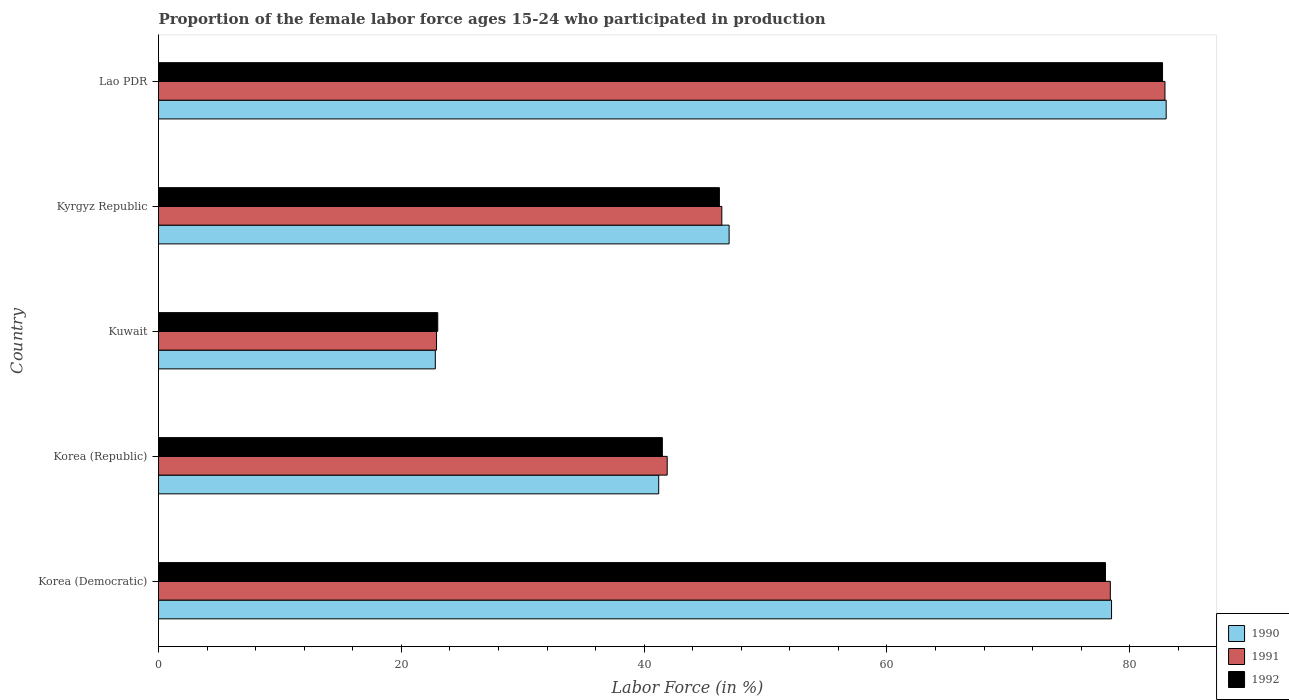How many groups of bars are there?
Your answer should be compact. 5. Are the number of bars on each tick of the Y-axis equal?
Keep it short and to the point. Yes. How many bars are there on the 2nd tick from the top?
Your answer should be very brief. 3. How many bars are there on the 4th tick from the bottom?
Offer a terse response. 3. What is the label of the 5th group of bars from the top?
Offer a terse response. Korea (Democratic). What is the proportion of the female labor force who participated in production in 1991 in Kyrgyz Republic?
Your answer should be compact. 46.4. Across all countries, what is the maximum proportion of the female labor force who participated in production in 1991?
Your answer should be compact. 82.9. Across all countries, what is the minimum proportion of the female labor force who participated in production in 1990?
Give a very brief answer. 22.8. In which country was the proportion of the female labor force who participated in production in 1991 maximum?
Give a very brief answer. Lao PDR. In which country was the proportion of the female labor force who participated in production in 1990 minimum?
Your response must be concise. Kuwait. What is the total proportion of the female labor force who participated in production in 1992 in the graph?
Provide a succinct answer. 271.4. What is the difference between the proportion of the female labor force who participated in production in 1992 in Korea (Democratic) and that in Lao PDR?
Provide a succinct answer. -4.7. What is the difference between the proportion of the female labor force who participated in production in 1991 in Lao PDR and the proportion of the female labor force who participated in production in 1992 in Kuwait?
Offer a terse response. 59.9. What is the average proportion of the female labor force who participated in production in 1992 per country?
Offer a very short reply. 54.28. What is the difference between the proportion of the female labor force who participated in production in 1990 and proportion of the female labor force who participated in production in 1992 in Korea (Republic)?
Keep it short and to the point. -0.3. In how many countries, is the proportion of the female labor force who participated in production in 1991 greater than 36 %?
Your answer should be very brief. 4. What is the ratio of the proportion of the female labor force who participated in production in 1990 in Kuwait to that in Lao PDR?
Offer a very short reply. 0.27. What is the difference between the highest and the second highest proportion of the female labor force who participated in production in 1991?
Your response must be concise. 4.5. What is the difference between the highest and the lowest proportion of the female labor force who participated in production in 1992?
Provide a short and direct response. 59.7. Is the sum of the proportion of the female labor force who participated in production in 1990 in Korea (Democratic) and Lao PDR greater than the maximum proportion of the female labor force who participated in production in 1992 across all countries?
Offer a terse response. Yes. What does the 2nd bar from the top in Korea (Republic) represents?
Give a very brief answer. 1991. What does the 2nd bar from the bottom in Kyrgyz Republic represents?
Keep it short and to the point. 1991. Is it the case that in every country, the sum of the proportion of the female labor force who participated in production in 1992 and proportion of the female labor force who participated in production in 1990 is greater than the proportion of the female labor force who participated in production in 1991?
Provide a short and direct response. Yes. Are all the bars in the graph horizontal?
Provide a succinct answer. Yes. What is the difference between two consecutive major ticks on the X-axis?
Your answer should be compact. 20. Are the values on the major ticks of X-axis written in scientific E-notation?
Make the answer very short. No. How many legend labels are there?
Offer a very short reply. 3. How are the legend labels stacked?
Ensure brevity in your answer.  Vertical. What is the title of the graph?
Your response must be concise. Proportion of the female labor force ages 15-24 who participated in production. What is the label or title of the X-axis?
Offer a terse response. Labor Force (in %). What is the label or title of the Y-axis?
Offer a terse response. Country. What is the Labor Force (in %) in 1990 in Korea (Democratic)?
Your response must be concise. 78.5. What is the Labor Force (in %) in 1991 in Korea (Democratic)?
Your answer should be compact. 78.4. What is the Labor Force (in %) of 1992 in Korea (Democratic)?
Offer a terse response. 78. What is the Labor Force (in %) of 1990 in Korea (Republic)?
Provide a short and direct response. 41.2. What is the Labor Force (in %) of 1991 in Korea (Republic)?
Provide a succinct answer. 41.9. What is the Labor Force (in %) of 1992 in Korea (Republic)?
Provide a succinct answer. 41.5. What is the Labor Force (in %) in 1990 in Kuwait?
Your response must be concise. 22.8. What is the Labor Force (in %) in 1991 in Kuwait?
Provide a succinct answer. 22.9. What is the Labor Force (in %) in 1992 in Kuwait?
Your answer should be very brief. 23. What is the Labor Force (in %) in 1990 in Kyrgyz Republic?
Provide a succinct answer. 47. What is the Labor Force (in %) of 1991 in Kyrgyz Republic?
Make the answer very short. 46.4. What is the Labor Force (in %) of 1992 in Kyrgyz Republic?
Offer a terse response. 46.2. What is the Labor Force (in %) of 1991 in Lao PDR?
Make the answer very short. 82.9. What is the Labor Force (in %) of 1992 in Lao PDR?
Offer a terse response. 82.7. Across all countries, what is the maximum Labor Force (in %) of 1991?
Your answer should be very brief. 82.9. Across all countries, what is the maximum Labor Force (in %) of 1992?
Give a very brief answer. 82.7. Across all countries, what is the minimum Labor Force (in %) of 1990?
Provide a succinct answer. 22.8. Across all countries, what is the minimum Labor Force (in %) of 1991?
Provide a succinct answer. 22.9. What is the total Labor Force (in %) of 1990 in the graph?
Make the answer very short. 272.5. What is the total Labor Force (in %) of 1991 in the graph?
Your response must be concise. 272.5. What is the total Labor Force (in %) of 1992 in the graph?
Keep it short and to the point. 271.4. What is the difference between the Labor Force (in %) of 1990 in Korea (Democratic) and that in Korea (Republic)?
Keep it short and to the point. 37.3. What is the difference between the Labor Force (in %) in 1991 in Korea (Democratic) and that in Korea (Republic)?
Ensure brevity in your answer.  36.5. What is the difference between the Labor Force (in %) in 1992 in Korea (Democratic) and that in Korea (Republic)?
Give a very brief answer. 36.5. What is the difference between the Labor Force (in %) in 1990 in Korea (Democratic) and that in Kuwait?
Your answer should be very brief. 55.7. What is the difference between the Labor Force (in %) of 1991 in Korea (Democratic) and that in Kuwait?
Keep it short and to the point. 55.5. What is the difference between the Labor Force (in %) of 1992 in Korea (Democratic) and that in Kuwait?
Offer a very short reply. 55. What is the difference between the Labor Force (in %) in 1990 in Korea (Democratic) and that in Kyrgyz Republic?
Make the answer very short. 31.5. What is the difference between the Labor Force (in %) in 1991 in Korea (Democratic) and that in Kyrgyz Republic?
Keep it short and to the point. 32. What is the difference between the Labor Force (in %) in 1992 in Korea (Democratic) and that in Kyrgyz Republic?
Give a very brief answer. 31.8. What is the difference between the Labor Force (in %) of 1991 in Korea (Democratic) and that in Lao PDR?
Provide a succinct answer. -4.5. What is the difference between the Labor Force (in %) of 1992 in Korea (Democratic) and that in Lao PDR?
Provide a short and direct response. -4.7. What is the difference between the Labor Force (in %) in 1992 in Korea (Republic) and that in Kuwait?
Ensure brevity in your answer.  18.5. What is the difference between the Labor Force (in %) in 1992 in Korea (Republic) and that in Kyrgyz Republic?
Your answer should be very brief. -4.7. What is the difference between the Labor Force (in %) of 1990 in Korea (Republic) and that in Lao PDR?
Make the answer very short. -41.8. What is the difference between the Labor Force (in %) in 1991 in Korea (Republic) and that in Lao PDR?
Keep it short and to the point. -41. What is the difference between the Labor Force (in %) of 1992 in Korea (Republic) and that in Lao PDR?
Offer a very short reply. -41.2. What is the difference between the Labor Force (in %) of 1990 in Kuwait and that in Kyrgyz Republic?
Offer a very short reply. -24.2. What is the difference between the Labor Force (in %) of 1991 in Kuwait and that in Kyrgyz Republic?
Make the answer very short. -23.5. What is the difference between the Labor Force (in %) in 1992 in Kuwait and that in Kyrgyz Republic?
Your answer should be compact. -23.2. What is the difference between the Labor Force (in %) in 1990 in Kuwait and that in Lao PDR?
Keep it short and to the point. -60.2. What is the difference between the Labor Force (in %) of 1991 in Kuwait and that in Lao PDR?
Offer a terse response. -60. What is the difference between the Labor Force (in %) in 1992 in Kuwait and that in Lao PDR?
Give a very brief answer. -59.7. What is the difference between the Labor Force (in %) in 1990 in Kyrgyz Republic and that in Lao PDR?
Make the answer very short. -36. What is the difference between the Labor Force (in %) of 1991 in Kyrgyz Republic and that in Lao PDR?
Offer a very short reply. -36.5. What is the difference between the Labor Force (in %) of 1992 in Kyrgyz Republic and that in Lao PDR?
Ensure brevity in your answer.  -36.5. What is the difference between the Labor Force (in %) in 1990 in Korea (Democratic) and the Labor Force (in %) in 1991 in Korea (Republic)?
Your answer should be compact. 36.6. What is the difference between the Labor Force (in %) of 1991 in Korea (Democratic) and the Labor Force (in %) of 1992 in Korea (Republic)?
Offer a very short reply. 36.9. What is the difference between the Labor Force (in %) in 1990 in Korea (Democratic) and the Labor Force (in %) in 1991 in Kuwait?
Your answer should be very brief. 55.6. What is the difference between the Labor Force (in %) of 1990 in Korea (Democratic) and the Labor Force (in %) of 1992 in Kuwait?
Give a very brief answer. 55.5. What is the difference between the Labor Force (in %) of 1991 in Korea (Democratic) and the Labor Force (in %) of 1992 in Kuwait?
Keep it short and to the point. 55.4. What is the difference between the Labor Force (in %) of 1990 in Korea (Democratic) and the Labor Force (in %) of 1991 in Kyrgyz Republic?
Your answer should be very brief. 32.1. What is the difference between the Labor Force (in %) in 1990 in Korea (Democratic) and the Labor Force (in %) in 1992 in Kyrgyz Republic?
Offer a terse response. 32.3. What is the difference between the Labor Force (in %) of 1991 in Korea (Democratic) and the Labor Force (in %) of 1992 in Kyrgyz Republic?
Your response must be concise. 32.2. What is the difference between the Labor Force (in %) in 1990 in Korea (Democratic) and the Labor Force (in %) in 1992 in Lao PDR?
Keep it short and to the point. -4.2. What is the difference between the Labor Force (in %) of 1991 in Korea (Democratic) and the Labor Force (in %) of 1992 in Lao PDR?
Offer a terse response. -4.3. What is the difference between the Labor Force (in %) in 1990 in Korea (Republic) and the Labor Force (in %) in 1991 in Kuwait?
Provide a succinct answer. 18.3. What is the difference between the Labor Force (in %) in 1990 in Korea (Republic) and the Labor Force (in %) in 1991 in Lao PDR?
Your answer should be very brief. -41.7. What is the difference between the Labor Force (in %) of 1990 in Korea (Republic) and the Labor Force (in %) of 1992 in Lao PDR?
Your answer should be very brief. -41.5. What is the difference between the Labor Force (in %) of 1991 in Korea (Republic) and the Labor Force (in %) of 1992 in Lao PDR?
Give a very brief answer. -40.8. What is the difference between the Labor Force (in %) in 1990 in Kuwait and the Labor Force (in %) in 1991 in Kyrgyz Republic?
Offer a very short reply. -23.6. What is the difference between the Labor Force (in %) of 1990 in Kuwait and the Labor Force (in %) of 1992 in Kyrgyz Republic?
Your answer should be very brief. -23.4. What is the difference between the Labor Force (in %) in 1991 in Kuwait and the Labor Force (in %) in 1992 in Kyrgyz Republic?
Your answer should be very brief. -23.3. What is the difference between the Labor Force (in %) in 1990 in Kuwait and the Labor Force (in %) in 1991 in Lao PDR?
Offer a very short reply. -60.1. What is the difference between the Labor Force (in %) in 1990 in Kuwait and the Labor Force (in %) in 1992 in Lao PDR?
Keep it short and to the point. -59.9. What is the difference between the Labor Force (in %) in 1991 in Kuwait and the Labor Force (in %) in 1992 in Lao PDR?
Keep it short and to the point. -59.8. What is the difference between the Labor Force (in %) of 1990 in Kyrgyz Republic and the Labor Force (in %) of 1991 in Lao PDR?
Make the answer very short. -35.9. What is the difference between the Labor Force (in %) of 1990 in Kyrgyz Republic and the Labor Force (in %) of 1992 in Lao PDR?
Offer a terse response. -35.7. What is the difference between the Labor Force (in %) in 1991 in Kyrgyz Republic and the Labor Force (in %) in 1992 in Lao PDR?
Give a very brief answer. -36.3. What is the average Labor Force (in %) in 1990 per country?
Provide a succinct answer. 54.5. What is the average Labor Force (in %) in 1991 per country?
Keep it short and to the point. 54.5. What is the average Labor Force (in %) in 1992 per country?
Provide a short and direct response. 54.28. What is the difference between the Labor Force (in %) in 1990 and Labor Force (in %) in 1992 in Korea (Republic)?
Ensure brevity in your answer.  -0.3. What is the difference between the Labor Force (in %) of 1990 and Labor Force (in %) of 1991 in Kuwait?
Ensure brevity in your answer.  -0.1. What is the difference between the Labor Force (in %) in 1991 and Labor Force (in %) in 1992 in Kuwait?
Provide a succinct answer. -0.1. What is the difference between the Labor Force (in %) in 1990 and Labor Force (in %) in 1991 in Kyrgyz Republic?
Your response must be concise. 0.6. What is the difference between the Labor Force (in %) in 1990 and Labor Force (in %) in 1992 in Kyrgyz Republic?
Offer a very short reply. 0.8. What is the difference between the Labor Force (in %) of 1991 and Labor Force (in %) of 1992 in Kyrgyz Republic?
Keep it short and to the point. 0.2. What is the difference between the Labor Force (in %) in 1990 and Labor Force (in %) in 1992 in Lao PDR?
Offer a terse response. 0.3. What is the ratio of the Labor Force (in %) in 1990 in Korea (Democratic) to that in Korea (Republic)?
Give a very brief answer. 1.91. What is the ratio of the Labor Force (in %) in 1991 in Korea (Democratic) to that in Korea (Republic)?
Offer a terse response. 1.87. What is the ratio of the Labor Force (in %) in 1992 in Korea (Democratic) to that in Korea (Republic)?
Provide a short and direct response. 1.88. What is the ratio of the Labor Force (in %) of 1990 in Korea (Democratic) to that in Kuwait?
Give a very brief answer. 3.44. What is the ratio of the Labor Force (in %) in 1991 in Korea (Democratic) to that in Kuwait?
Keep it short and to the point. 3.42. What is the ratio of the Labor Force (in %) in 1992 in Korea (Democratic) to that in Kuwait?
Make the answer very short. 3.39. What is the ratio of the Labor Force (in %) in 1990 in Korea (Democratic) to that in Kyrgyz Republic?
Give a very brief answer. 1.67. What is the ratio of the Labor Force (in %) of 1991 in Korea (Democratic) to that in Kyrgyz Republic?
Keep it short and to the point. 1.69. What is the ratio of the Labor Force (in %) in 1992 in Korea (Democratic) to that in Kyrgyz Republic?
Your response must be concise. 1.69. What is the ratio of the Labor Force (in %) of 1990 in Korea (Democratic) to that in Lao PDR?
Offer a very short reply. 0.95. What is the ratio of the Labor Force (in %) of 1991 in Korea (Democratic) to that in Lao PDR?
Give a very brief answer. 0.95. What is the ratio of the Labor Force (in %) of 1992 in Korea (Democratic) to that in Lao PDR?
Make the answer very short. 0.94. What is the ratio of the Labor Force (in %) in 1990 in Korea (Republic) to that in Kuwait?
Offer a terse response. 1.81. What is the ratio of the Labor Force (in %) of 1991 in Korea (Republic) to that in Kuwait?
Offer a terse response. 1.83. What is the ratio of the Labor Force (in %) of 1992 in Korea (Republic) to that in Kuwait?
Give a very brief answer. 1.8. What is the ratio of the Labor Force (in %) of 1990 in Korea (Republic) to that in Kyrgyz Republic?
Provide a succinct answer. 0.88. What is the ratio of the Labor Force (in %) in 1991 in Korea (Republic) to that in Kyrgyz Republic?
Keep it short and to the point. 0.9. What is the ratio of the Labor Force (in %) in 1992 in Korea (Republic) to that in Kyrgyz Republic?
Make the answer very short. 0.9. What is the ratio of the Labor Force (in %) of 1990 in Korea (Republic) to that in Lao PDR?
Make the answer very short. 0.5. What is the ratio of the Labor Force (in %) in 1991 in Korea (Republic) to that in Lao PDR?
Your answer should be compact. 0.51. What is the ratio of the Labor Force (in %) of 1992 in Korea (Republic) to that in Lao PDR?
Provide a short and direct response. 0.5. What is the ratio of the Labor Force (in %) of 1990 in Kuwait to that in Kyrgyz Republic?
Offer a terse response. 0.49. What is the ratio of the Labor Force (in %) of 1991 in Kuwait to that in Kyrgyz Republic?
Provide a short and direct response. 0.49. What is the ratio of the Labor Force (in %) of 1992 in Kuwait to that in Kyrgyz Republic?
Offer a terse response. 0.5. What is the ratio of the Labor Force (in %) in 1990 in Kuwait to that in Lao PDR?
Provide a succinct answer. 0.27. What is the ratio of the Labor Force (in %) of 1991 in Kuwait to that in Lao PDR?
Give a very brief answer. 0.28. What is the ratio of the Labor Force (in %) of 1992 in Kuwait to that in Lao PDR?
Ensure brevity in your answer.  0.28. What is the ratio of the Labor Force (in %) in 1990 in Kyrgyz Republic to that in Lao PDR?
Give a very brief answer. 0.57. What is the ratio of the Labor Force (in %) of 1991 in Kyrgyz Republic to that in Lao PDR?
Give a very brief answer. 0.56. What is the ratio of the Labor Force (in %) in 1992 in Kyrgyz Republic to that in Lao PDR?
Your answer should be very brief. 0.56. What is the difference between the highest and the second highest Labor Force (in %) of 1992?
Your answer should be compact. 4.7. What is the difference between the highest and the lowest Labor Force (in %) in 1990?
Provide a short and direct response. 60.2. What is the difference between the highest and the lowest Labor Force (in %) in 1991?
Keep it short and to the point. 60. What is the difference between the highest and the lowest Labor Force (in %) in 1992?
Provide a short and direct response. 59.7. 